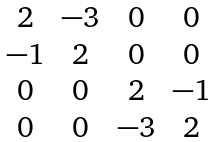<formula> <loc_0><loc_0><loc_500><loc_500>\begin{matrix} 2 & - 3 & 0 & 0 \\ - 1 & 2 & 0 & 0 \\ 0 & 0 & 2 & - 1 \\ 0 & 0 & - 3 & 2 \end{matrix}</formula> 